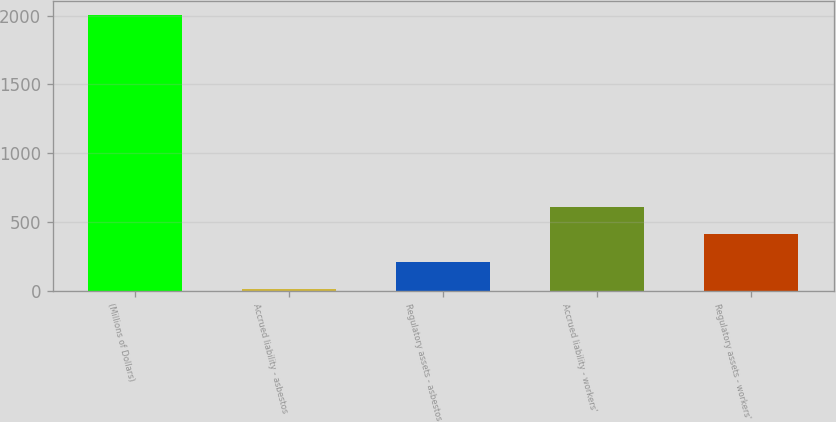Convert chart. <chart><loc_0><loc_0><loc_500><loc_500><bar_chart><fcel>(Millions of Dollars)<fcel>Accrued liability - asbestos<fcel>Regulatory assets - asbestos<fcel>Accrued liability - workers'<fcel>Regulatory assets - workers'<nl><fcel>2009<fcel>9<fcel>209<fcel>609<fcel>409<nl></chart> 